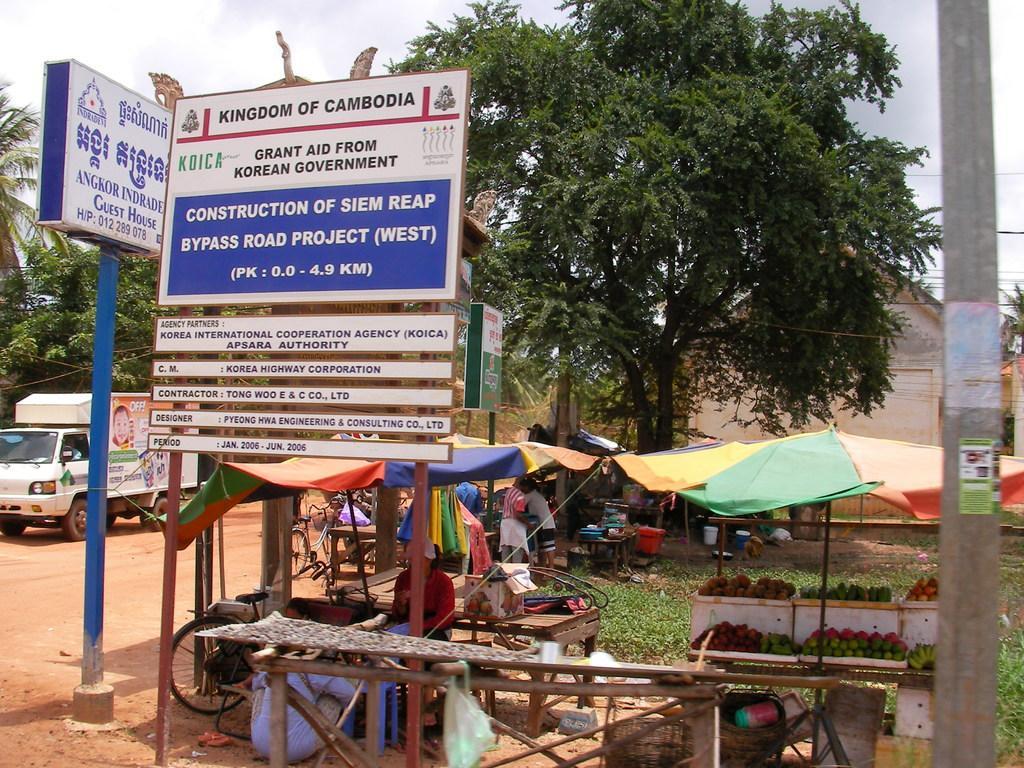Please provide a concise description of this image. In this picture I can see the boards, advertisement board, poles, trees, tent, tables and grass. In the centre there are two persons who are standing near to the tent and table. On the table I can see many fruits. On the left there is a man who is sitting inside the white truck. In the back I can see the shed. At the top I can see the sky and clouds. On the right I can see electric poles and wires are connected to it. In the bottom left there is a bicycle, beside that I can see some people were sitting on the chair. 